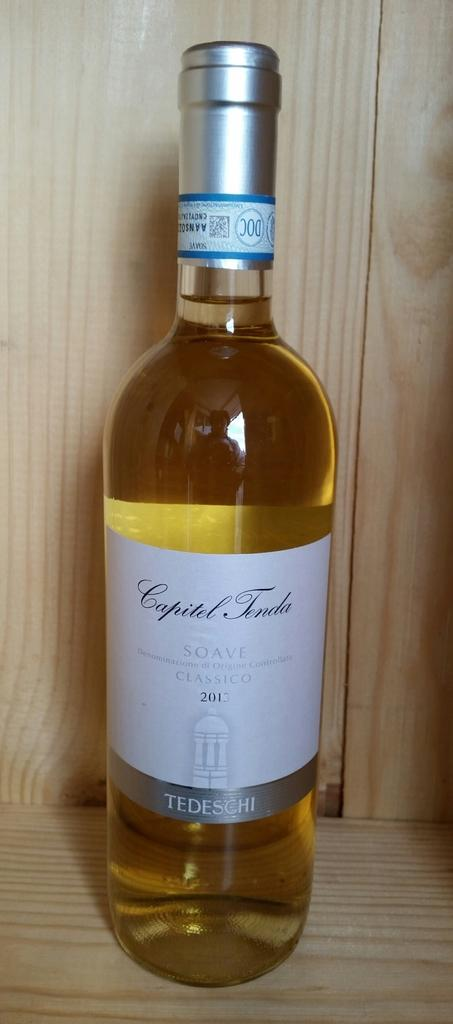<image>
Write a terse but informative summary of the picture. A glass bottle with Capitel Tenda Soave wine from 2013 with a white label and silver boarder. 